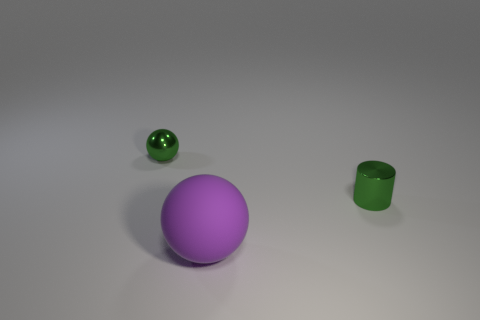How many shiny objects are either big balls or big brown things?
Keep it short and to the point. 0. There is a small metallic thing that is the same shape as the large thing; what is its color?
Offer a terse response. Green. Are there any green cylinders?
Make the answer very short. Yes. Are the small thing that is right of the large thing and the sphere behind the big rubber thing made of the same material?
Provide a succinct answer. Yes. What shape is the tiny thing that is the same color as the small sphere?
Your answer should be very brief. Cylinder. How many objects are either small things that are left of the purple object or small green shiny things that are on the left side of the cylinder?
Provide a short and direct response. 1. Does the tiny metallic ball on the left side of the large purple matte ball have the same color as the small shiny object that is right of the large matte ball?
Offer a very short reply. Yes. What is the shape of the thing that is left of the cylinder and behind the purple thing?
Your response must be concise. Sphere. There is a metallic object that is the same size as the metallic cylinder; what color is it?
Provide a short and direct response. Green. Are there any tiny cubes of the same color as the small sphere?
Give a very brief answer. No. 